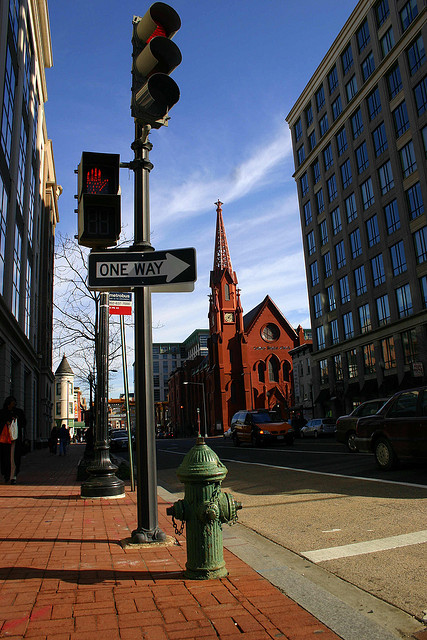Can you tell me about the significance of the red color on the church? The red color on the church could be significant for several reasons. It may represent the church's heritage, as red is often associated with strength and power. Additionally, the vivid color stands out in an urban environment and may denote a place of importance or sanctuary. 